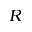Convert formula to latex. <formula><loc_0><loc_0><loc_500><loc_500>R</formula> 